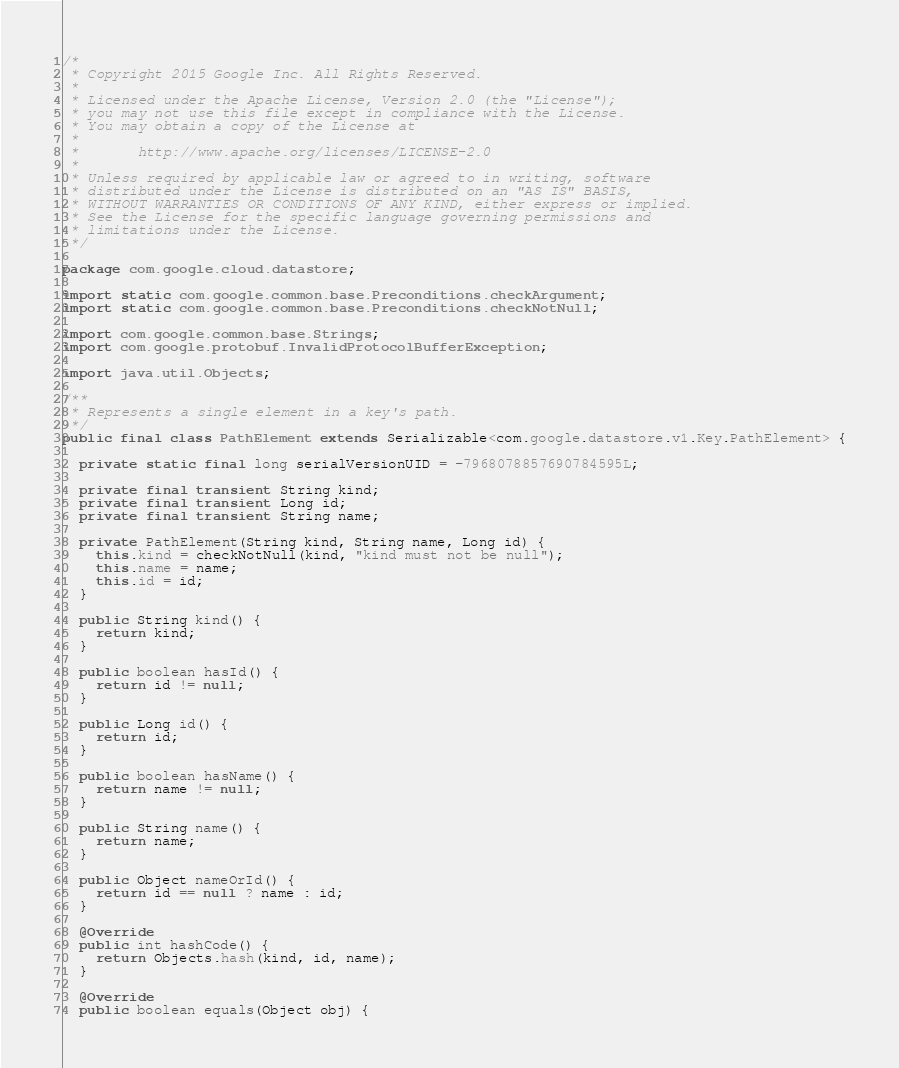<code> <loc_0><loc_0><loc_500><loc_500><_Java_>/*
 * Copyright 2015 Google Inc. All Rights Reserved.
 *
 * Licensed under the Apache License, Version 2.0 (the "License");
 * you may not use this file except in compliance with the License.
 * You may obtain a copy of the License at
 *
 *       http://www.apache.org/licenses/LICENSE-2.0
 *
 * Unless required by applicable law or agreed to in writing, software
 * distributed under the License is distributed on an "AS IS" BASIS,
 * WITHOUT WARRANTIES OR CONDITIONS OF ANY KIND, either express or implied.
 * See the License for the specific language governing permissions and
 * limitations under the License.
 */

package com.google.cloud.datastore;

import static com.google.common.base.Preconditions.checkArgument;
import static com.google.common.base.Preconditions.checkNotNull;

import com.google.common.base.Strings;
import com.google.protobuf.InvalidProtocolBufferException;

import java.util.Objects;

/**
 * Represents a single element in a key's path.
 */
public final class PathElement extends Serializable<com.google.datastore.v1.Key.PathElement> {

  private static final long serialVersionUID = -7968078857690784595L;

  private final transient String kind;
  private final transient Long id;
  private final transient String name;

  private PathElement(String kind, String name, Long id) {
    this.kind = checkNotNull(kind, "kind must not be null");
    this.name = name;
    this.id = id;
  }

  public String kind() {
    return kind;
  }

  public boolean hasId() {
    return id != null;
  }

  public Long id() {
    return id;
  }

  public boolean hasName() {
    return name != null;
  }

  public String name() {
    return name;
  }

  public Object nameOrId() {
    return id == null ? name : id;
  }

  @Override
  public int hashCode() {
    return Objects.hash(kind, id, name);
  }

  @Override
  public boolean equals(Object obj) {</code> 